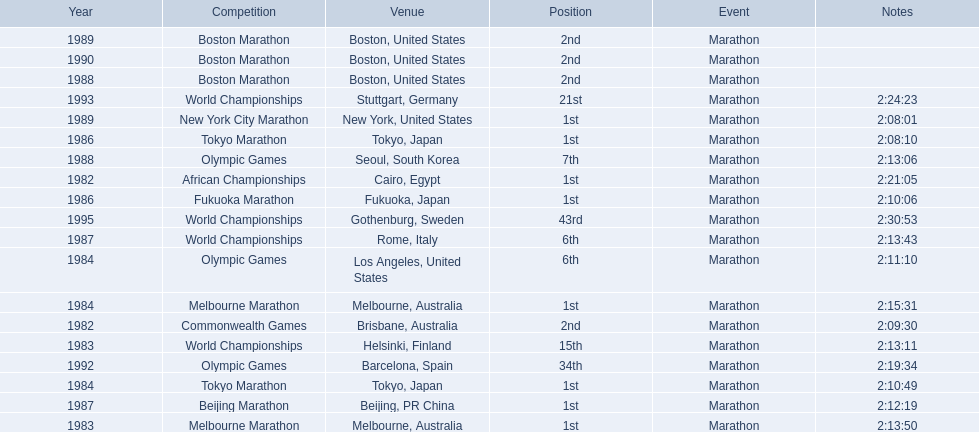What are the competitions? African Championships, Cairo, Egypt, Commonwealth Games, Brisbane, Australia, World Championships, Helsinki, Finland, Melbourne Marathon, Melbourne, Australia, Tokyo Marathon, Tokyo, Japan, Olympic Games, Los Angeles, United States, Melbourne Marathon, Melbourne, Australia, Tokyo Marathon, Tokyo, Japan, Fukuoka Marathon, Fukuoka, Japan, World Championships, Rome, Italy, Beijing Marathon, Beijing, PR China, Olympic Games, Seoul, South Korea, Boston Marathon, Boston, United States, New York City Marathon, New York, United States, Boston Marathon, Boston, United States, Boston Marathon, Boston, United States, Olympic Games, Barcelona, Spain, World Championships, Stuttgart, Germany, World Championships, Gothenburg, Sweden. Which ones occured in china? Beijing Marathon, Beijing, PR China. Which one is it? Beijing Marathon. 